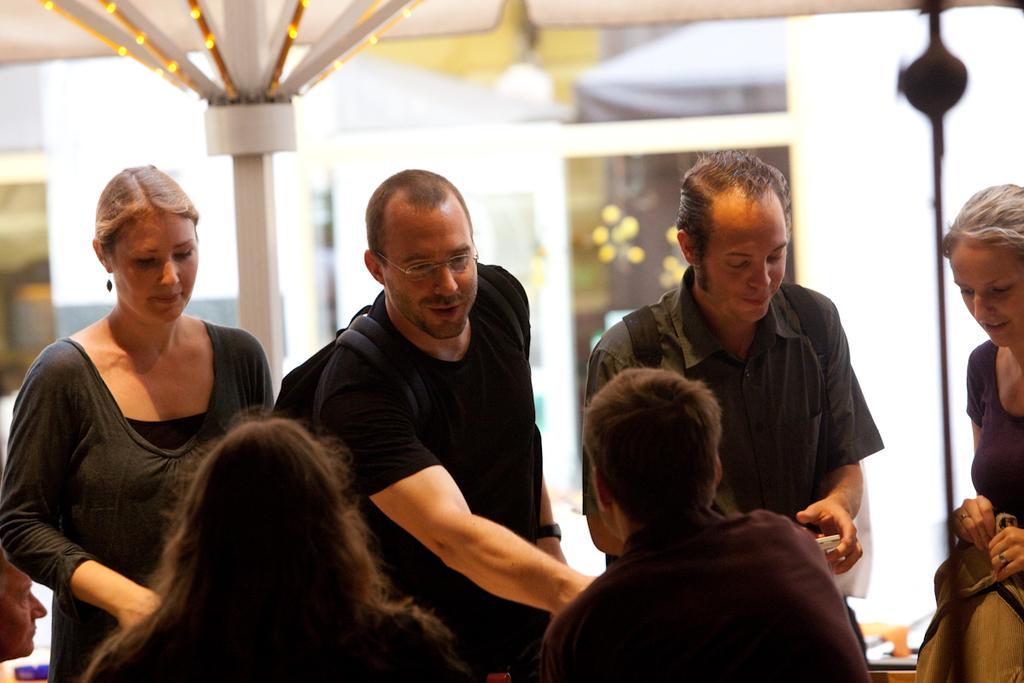How would you summarize this image in a sentence or two? In the foreground of this picture we can see the group of persons. In the center we can see the two persons wearing backpacks and standing. On the right corner we can see a woman holding an object and standing. In the background we can see the decoration lights, wall and some other objects. 